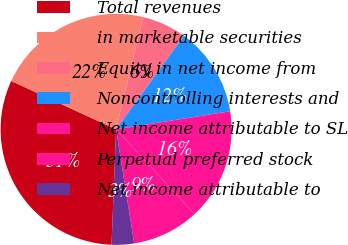Convert chart. <chart><loc_0><loc_0><loc_500><loc_500><pie_chart><fcel>Total revenues<fcel>in marketable securities<fcel>Equity in net income from<fcel>Noncontrolling interests and<fcel>Net income attributable to SL<fcel>Perpetual preferred stock<fcel>Net income attributable to<nl><fcel>31.25%<fcel>21.87%<fcel>6.25%<fcel>12.5%<fcel>15.62%<fcel>9.38%<fcel>3.13%<nl></chart> 